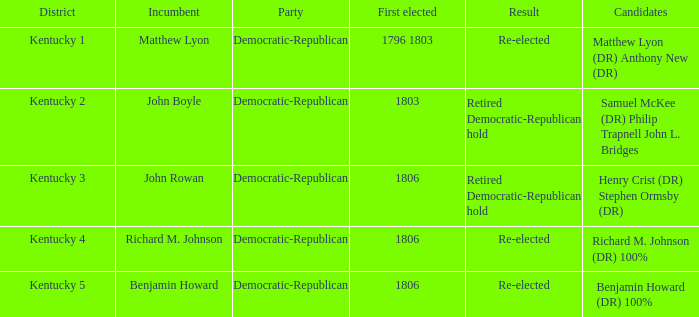Name the number of first elected for kentucky 3 1.0. Could you parse the entire table? {'header': ['District', 'Incumbent', 'Party', 'First elected', 'Result', 'Candidates'], 'rows': [['Kentucky 1', 'Matthew Lyon', 'Democratic-Republican', '1796 1803', 'Re-elected', 'Matthew Lyon (DR) Anthony New (DR)'], ['Kentucky 2', 'John Boyle', 'Democratic-Republican', '1803', 'Retired Democratic-Republican hold', 'Samuel McKee (DR) Philip Trapnell John L. Bridges'], ['Kentucky 3', 'John Rowan', 'Democratic-Republican', '1806', 'Retired Democratic-Republican hold', 'Henry Crist (DR) Stephen Ormsby (DR)'], ['Kentucky 4', 'Richard M. Johnson', 'Democratic-Republican', '1806', 'Re-elected', 'Richard M. Johnson (DR) 100%'], ['Kentucky 5', 'Benjamin Howard', 'Democratic-Republican', '1806', 'Re-elected', 'Benjamin Howard (DR) 100%']]} 